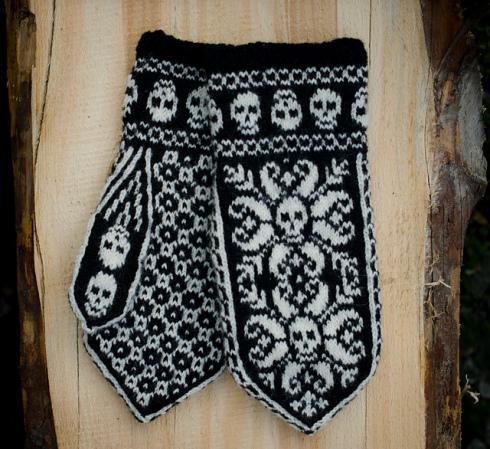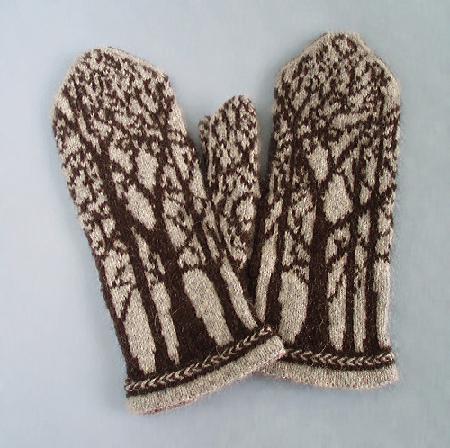The first image is the image on the left, the second image is the image on the right. Assess this claim about the two images: "At least one pair of mittens features a pointed, triangular shaped top, rather than a rounded one.". Correct or not? Answer yes or no. Yes. The first image is the image on the left, the second image is the image on the right. Considering the images on both sides, is "One image had a clear,wooden background surface." valid? Answer yes or no. Yes. 